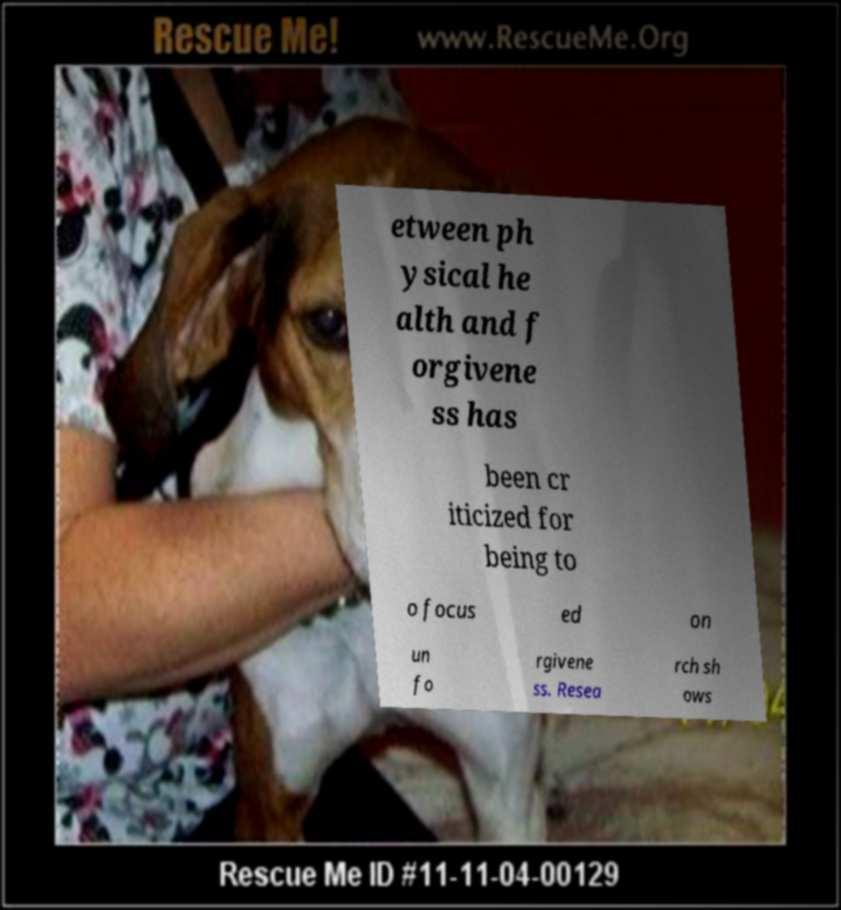For documentation purposes, I need the text within this image transcribed. Could you provide that? etween ph ysical he alth and f orgivene ss has been cr iticized for being to o focus ed on un fo rgivene ss. Resea rch sh ows 